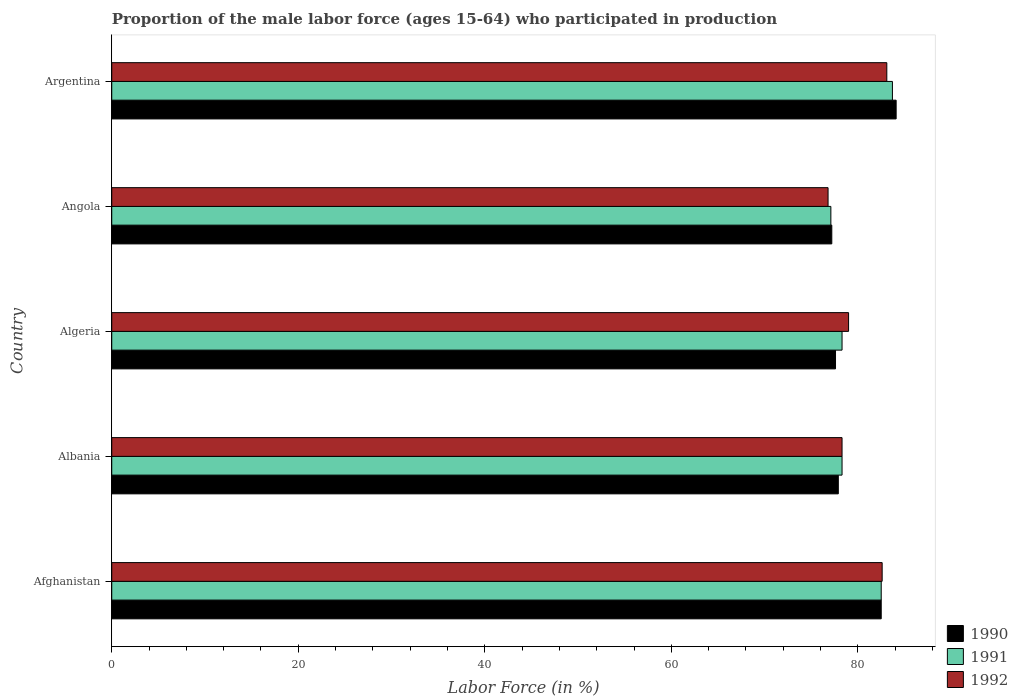How many different coloured bars are there?
Provide a short and direct response. 3. How many bars are there on the 2nd tick from the bottom?
Your response must be concise. 3. What is the label of the 2nd group of bars from the top?
Provide a short and direct response. Angola. In how many cases, is the number of bars for a given country not equal to the number of legend labels?
Make the answer very short. 0. What is the proportion of the male labor force who participated in production in 1991 in Albania?
Give a very brief answer. 78.3. Across all countries, what is the maximum proportion of the male labor force who participated in production in 1991?
Your answer should be compact. 83.7. Across all countries, what is the minimum proportion of the male labor force who participated in production in 1992?
Offer a terse response. 76.8. In which country was the proportion of the male labor force who participated in production in 1990 minimum?
Offer a very short reply. Angola. What is the total proportion of the male labor force who participated in production in 1992 in the graph?
Keep it short and to the point. 399.8. What is the difference between the proportion of the male labor force who participated in production in 1991 in Albania and that in Argentina?
Give a very brief answer. -5.4. What is the difference between the proportion of the male labor force who participated in production in 1992 in Albania and the proportion of the male labor force who participated in production in 1990 in Angola?
Provide a succinct answer. 1.1. What is the average proportion of the male labor force who participated in production in 1992 per country?
Provide a succinct answer. 79.96. What is the difference between the proportion of the male labor force who participated in production in 1990 and proportion of the male labor force who participated in production in 1992 in Afghanistan?
Make the answer very short. -0.1. In how many countries, is the proportion of the male labor force who participated in production in 1992 greater than 24 %?
Give a very brief answer. 5. What is the ratio of the proportion of the male labor force who participated in production in 1990 in Albania to that in Algeria?
Provide a succinct answer. 1. Is the proportion of the male labor force who participated in production in 1991 in Afghanistan less than that in Argentina?
Offer a terse response. Yes. What is the difference between the highest and the second highest proportion of the male labor force who participated in production in 1991?
Your answer should be very brief. 1.2. What is the difference between the highest and the lowest proportion of the male labor force who participated in production in 1990?
Give a very brief answer. 6.9. In how many countries, is the proportion of the male labor force who participated in production in 1990 greater than the average proportion of the male labor force who participated in production in 1990 taken over all countries?
Your response must be concise. 2. What does the 2nd bar from the bottom in Albania represents?
Give a very brief answer. 1991. Is it the case that in every country, the sum of the proportion of the male labor force who participated in production in 1992 and proportion of the male labor force who participated in production in 1990 is greater than the proportion of the male labor force who participated in production in 1991?
Your answer should be compact. Yes. How many bars are there?
Make the answer very short. 15. How many countries are there in the graph?
Give a very brief answer. 5. What is the difference between two consecutive major ticks on the X-axis?
Keep it short and to the point. 20. Are the values on the major ticks of X-axis written in scientific E-notation?
Keep it short and to the point. No. Does the graph contain any zero values?
Your answer should be very brief. No. Where does the legend appear in the graph?
Your answer should be compact. Bottom right. How many legend labels are there?
Your answer should be compact. 3. How are the legend labels stacked?
Keep it short and to the point. Vertical. What is the title of the graph?
Your answer should be compact. Proportion of the male labor force (ages 15-64) who participated in production. Does "1982" appear as one of the legend labels in the graph?
Offer a very short reply. No. What is the Labor Force (in %) of 1990 in Afghanistan?
Your answer should be very brief. 82.5. What is the Labor Force (in %) in 1991 in Afghanistan?
Provide a succinct answer. 82.5. What is the Labor Force (in %) in 1992 in Afghanistan?
Offer a very short reply. 82.6. What is the Labor Force (in %) in 1990 in Albania?
Your answer should be very brief. 77.9. What is the Labor Force (in %) in 1991 in Albania?
Give a very brief answer. 78.3. What is the Labor Force (in %) of 1992 in Albania?
Make the answer very short. 78.3. What is the Labor Force (in %) of 1990 in Algeria?
Offer a terse response. 77.6. What is the Labor Force (in %) in 1991 in Algeria?
Provide a succinct answer. 78.3. What is the Labor Force (in %) of 1992 in Algeria?
Provide a short and direct response. 79. What is the Labor Force (in %) of 1990 in Angola?
Offer a very short reply. 77.2. What is the Labor Force (in %) in 1991 in Angola?
Your answer should be very brief. 77.1. What is the Labor Force (in %) in 1992 in Angola?
Give a very brief answer. 76.8. What is the Labor Force (in %) in 1990 in Argentina?
Provide a short and direct response. 84.1. What is the Labor Force (in %) in 1991 in Argentina?
Make the answer very short. 83.7. What is the Labor Force (in %) in 1992 in Argentina?
Provide a succinct answer. 83.1. Across all countries, what is the maximum Labor Force (in %) in 1990?
Ensure brevity in your answer.  84.1. Across all countries, what is the maximum Labor Force (in %) of 1991?
Give a very brief answer. 83.7. Across all countries, what is the maximum Labor Force (in %) of 1992?
Ensure brevity in your answer.  83.1. Across all countries, what is the minimum Labor Force (in %) of 1990?
Your answer should be very brief. 77.2. Across all countries, what is the minimum Labor Force (in %) of 1991?
Your answer should be very brief. 77.1. Across all countries, what is the minimum Labor Force (in %) in 1992?
Ensure brevity in your answer.  76.8. What is the total Labor Force (in %) in 1990 in the graph?
Make the answer very short. 399.3. What is the total Labor Force (in %) in 1991 in the graph?
Give a very brief answer. 399.9. What is the total Labor Force (in %) in 1992 in the graph?
Provide a succinct answer. 399.8. What is the difference between the Labor Force (in %) in 1990 in Afghanistan and that in Albania?
Ensure brevity in your answer.  4.6. What is the difference between the Labor Force (in %) in 1991 in Afghanistan and that in Algeria?
Offer a very short reply. 4.2. What is the difference between the Labor Force (in %) in 1992 in Afghanistan and that in Algeria?
Your answer should be compact. 3.6. What is the difference between the Labor Force (in %) in 1990 in Afghanistan and that in Angola?
Keep it short and to the point. 5.3. What is the difference between the Labor Force (in %) in 1991 in Afghanistan and that in Angola?
Keep it short and to the point. 5.4. What is the difference between the Labor Force (in %) in 1991 in Afghanistan and that in Argentina?
Offer a very short reply. -1.2. What is the difference between the Labor Force (in %) in 1990 in Albania and that in Algeria?
Your answer should be very brief. 0.3. What is the difference between the Labor Force (in %) of 1992 in Albania and that in Algeria?
Provide a succinct answer. -0.7. What is the difference between the Labor Force (in %) of 1991 in Albania and that in Angola?
Offer a very short reply. 1.2. What is the difference between the Labor Force (in %) in 1990 in Albania and that in Argentina?
Offer a terse response. -6.2. What is the difference between the Labor Force (in %) in 1991 in Algeria and that in Angola?
Give a very brief answer. 1.2. What is the difference between the Labor Force (in %) of 1990 in Algeria and that in Argentina?
Your answer should be very brief. -6.5. What is the difference between the Labor Force (in %) of 1990 in Angola and that in Argentina?
Your answer should be compact. -6.9. What is the difference between the Labor Force (in %) of 1991 in Angola and that in Argentina?
Provide a succinct answer. -6.6. What is the difference between the Labor Force (in %) of 1992 in Angola and that in Argentina?
Your answer should be compact. -6.3. What is the difference between the Labor Force (in %) in 1991 in Afghanistan and the Labor Force (in %) in 1992 in Albania?
Keep it short and to the point. 4.2. What is the difference between the Labor Force (in %) of 1991 in Afghanistan and the Labor Force (in %) of 1992 in Algeria?
Offer a very short reply. 3.5. What is the difference between the Labor Force (in %) of 1990 in Afghanistan and the Labor Force (in %) of 1991 in Angola?
Your response must be concise. 5.4. What is the difference between the Labor Force (in %) in 1991 in Afghanistan and the Labor Force (in %) in 1992 in Angola?
Your response must be concise. 5.7. What is the difference between the Labor Force (in %) in 1990 in Afghanistan and the Labor Force (in %) in 1991 in Argentina?
Make the answer very short. -1.2. What is the difference between the Labor Force (in %) in 1990 in Albania and the Labor Force (in %) in 1991 in Algeria?
Provide a short and direct response. -0.4. What is the difference between the Labor Force (in %) of 1990 in Albania and the Labor Force (in %) of 1992 in Algeria?
Provide a short and direct response. -1.1. What is the difference between the Labor Force (in %) of 1990 in Albania and the Labor Force (in %) of 1991 in Angola?
Provide a succinct answer. 0.8. What is the difference between the Labor Force (in %) of 1990 in Albania and the Labor Force (in %) of 1992 in Angola?
Provide a short and direct response. 1.1. What is the difference between the Labor Force (in %) of 1990 in Albania and the Labor Force (in %) of 1992 in Argentina?
Offer a very short reply. -5.2. What is the difference between the Labor Force (in %) of 1991 in Albania and the Labor Force (in %) of 1992 in Argentina?
Offer a very short reply. -4.8. What is the difference between the Labor Force (in %) in 1991 in Algeria and the Labor Force (in %) in 1992 in Angola?
Offer a very short reply. 1.5. What is the difference between the Labor Force (in %) of 1991 in Algeria and the Labor Force (in %) of 1992 in Argentina?
Ensure brevity in your answer.  -4.8. What is the difference between the Labor Force (in %) in 1990 in Angola and the Labor Force (in %) in 1991 in Argentina?
Keep it short and to the point. -6.5. What is the average Labor Force (in %) of 1990 per country?
Provide a succinct answer. 79.86. What is the average Labor Force (in %) of 1991 per country?
Your answer should be compact. 79.98. What is the average Labor Force (in %) in 1992 per country?
Make the answer very short. 79.96. What is the difference between the Labor Force (in %) of 1990 and Labor Force (in %) of 1991 in Afghanistan?
Provide a succinct answer. 0. What is the difference between the Labor Force (in %) of 1990 and Labor Force (in %) of 1991 in Albania?
Make the answer very short. -0.4. What is the difference between the Labor Force (in %) in 1991 and Labor Force (in %) in 1992 in Algeria?
Your answer should be very brief. -0.7. What is the difference between the Labor Force (in %) of 1990 and Labor Force (in %) of 1991 in Angola?
Keep it short and to the point. 0.1. What is the difference between the Labor Force (in %) of 1990 and Labor Force (in %) of 1991 in Argentina?
Your response must be concise. 0.4. What is the difference between the Labor Force (in %) of 1990 and Labor Force (in %) of 1992 in Argentina?
Provide a succinct answer. 1. What is the ratio of the Labor Force (in %) of 1990 in Afghanistan to that in Albania?
Ensure brevity in your answer.  1.06. What is the ratio of the Labor Force (in %) in 1991 in Afghanistan to that in Albania?
Your answer should be compact. 1.05. What is the ratio of the Labor Force (in %) in 1992 in Afghanistan to that in Albania?
Your answer should be very brief. 1.05. What is the ratio of the Labor Force (in %) in 1990 in Afghanistan to that in Algeria?
Your answer should be compact. 1.06. What is the ratio of the Labor Force (in %) in 1991 in Afghanistan to that in Algeria?
Keep it short and to the point. 1.05. What is the ratio of the Labor Force (in %) in 1992 in Afghanistan to that in Algeria?
Ensure brevity in your answer.  1.05. What is the ratio of the Labor Force (in %) in 1990 in Afghanistan to that in Angola?
Ensure brevity in your answer.  1.07. What is the ratio of the Labor Force (in %) in 1991 in Afghanistan to that in Angola?
Provide a short and direct response. 1.07. What is the ratio of the Labor Force (in %) of 1992 in Afghanistan to that in Angola?
Your answer should be compact. 1.08. What is the ratio of the Labor Force (in %) of 1990 in Afghanistan to that in Argentina?
Ensure brevity in your answer.  0.98. What is the ratio of the Labor Force (in %) of 1991 in Afghanistan to that in Argentina?
Keep it short and to the point. 0.99. What is the ratio of the Labor Force (in %) of 1992 in Afghanistan to that in Argentina?
Your answer should be very brief. 0.99. What is the ratio of the Labor Force (in %) of 1990 in Albania to that in Algeria?
Ensure brevity in your answer.  1. What is the ratio of the Labor Force (in %) of 1990 in Albania to that in Angola?
Ensure brevity in your answer.  1.01. What is the ratio of the Labor Force (in %) in 1991 in Albania to that in Angola?
Give a very brief answer. 1.02. What is the ratio of the Labor Force (in %) in 1992 in Albania to that in Angola?
Ensure brevity in your answer.  1.02. What is the ratio of the Labor Force (in %) of 1990 in Albania to that in Argentina?
Offer a very short reply. 0.93. What is the ratio of the Labor Force (in %) of 1991 in Albania to that in Argentina?
Your response must be concise. 0.94. What is the ratio of the Labor Force (in %) of 1992 in Albania to that in Argentina?
Ensure brevity in your answer.  0.94. What is the ratio of the Labor Force (in %) of 1991 in Algeria to that in Angola?
Offer a terse response. 1.02. What is the ratio of the Labor Force (in %) of 1992 in Algeria to that in Angola?
Make the answer very short. 1.03. What is the ratio of the Labor Force (in %) of 1990 in Algeria to that in Argentina?
Make the answer very short. 0.92. What is the ratio of the Labor Force (in %) of 1991 in Algeria to that in Argentina?
Your answer should be very brief. 0.94. What is the ratio of the Labor Force (in %) of 1992 in Algeria to that in Argentina?
Provide a succinct answer. 0.95. What is the ratio of the Labor Force (in %) in 1990 in Angola to that in Argentina?
Ensure brevity in your answer.  0.92. What is the ratio of the Labor Force (in %) in 1991 in Angola to that in Argentina?
Keep it short and to the point. 0.92. What is the ratio of the Labor Force (in %) in 1992 in Angola to that in Argentina?
Provide a short and direct response. 0.92. What is the difference between the highest and the second highest Labor Force (in %) of 1990?
Your response must be concise. 1.6. What is the difference between the highest and the second highest Labor Force (in %) of 1991?
Make the answer very short. 1.2. What is the difference between the highest and the second highest Labor Force (in %) of 1992?
Your response must be concise. 0.5. What is the difference between the highest and the lowest Labor Force (in %) in 1990?
Make the answer very short. 6.9. 